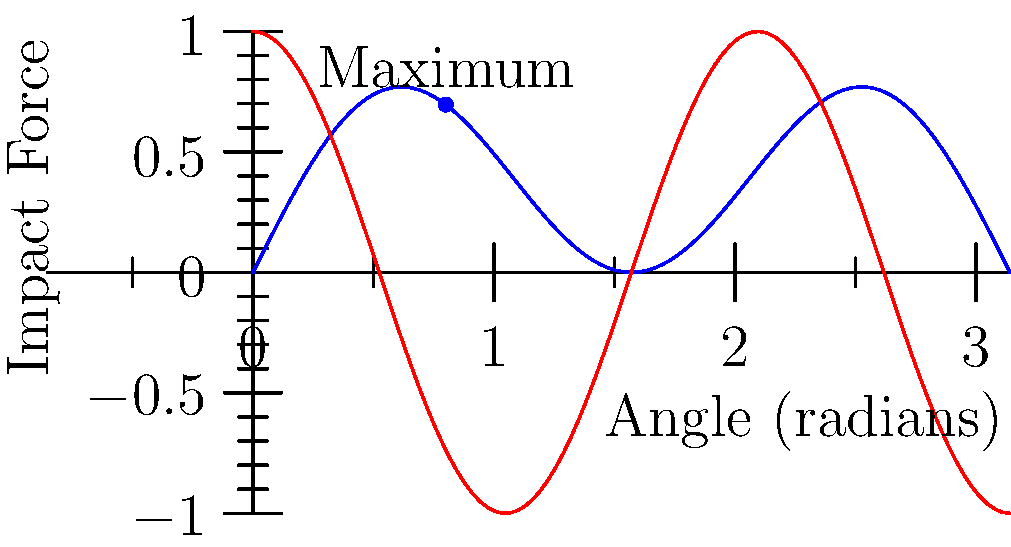In a new TMNT adventure, Michelangelo is perfecting his nunchaku technique. The impact force of his swing is modeled by the function $f(\theta) = \sin(2\theta)\cos(\theta)$, where $\theta$ is the angle of the swing in radians. What is the optimal angle for Mikey to swing his nunchaku to achieve maximum impact force? Round your answer to two decimal places. To find the optimal angle for maximum impact force, we need to follow these steps:

1) The maximum of the function occurs where its derivative is zero. Let's find the derivative of $f(\theta)$.

2) Using the product rule:
   $f'(\theta) = \frac{d}{d\theta}[\sin(2\theta)]\cos(\theta) + \sin(2\theta)\frac{d}{d\theta}[\cos(\theta)]$
   $f'(\theta) = 2\cos(2\theta)\cos(\theta) - \sin(2\theta)\sin(\theta)$

3) Set $f'(\theta) = 0$:
   $2\cos(2\theta)\cos(\theta) - \sin(2\theta)\sin(\theta) = 0$

4) Use the trigonometric identity $\sin(2\theta) = 2\sin(\theta)\cos(\theta)$:
   $2\cos(2\theta)\cos(\theta) - 2\sin(\theta)\cos(\theta)\sin(\theta) = 0$

5) Factor out $2\cos(\theta)$:
   $2\cos(\theta)[\cos(2\theta) - \sin^2(\theta)] = 0$

6) This equation is satisfied when either $\cos(\theta) = 0$ or $\cos(2\theta) = \sin^2(\theta)$

7) $\cos(\theta) = 0$ when $\theta = \frac{\pi}{2}$, but this gives $f(\frac{\pi}{2}) = 0$, which is not the maximum.

8) For $\cos(2\theta) = \sin^2(\theta)$, we can use $\cos(2\theta) = 1 - 2\sin^2(\theta)$:
   $1 - 2\sin^2(\theta) = \sin^2(\theta)$
   $1 = 3\sin^2(\theta)$
   $\sin^2(\theta) = \frac{1}{3}$
   $\theta = \arcsin(\frac{1}{\sqrt{3}})$

9) This gives us $\theta \approx 0.6155$ radians

10) To verify this is a maximum, we could check the second derivative is negative at this point.

Therefore, the optimal angle for Mikey to swing his nunchaku is approximately 0.62 radians.
Answer: 0.62 radians 